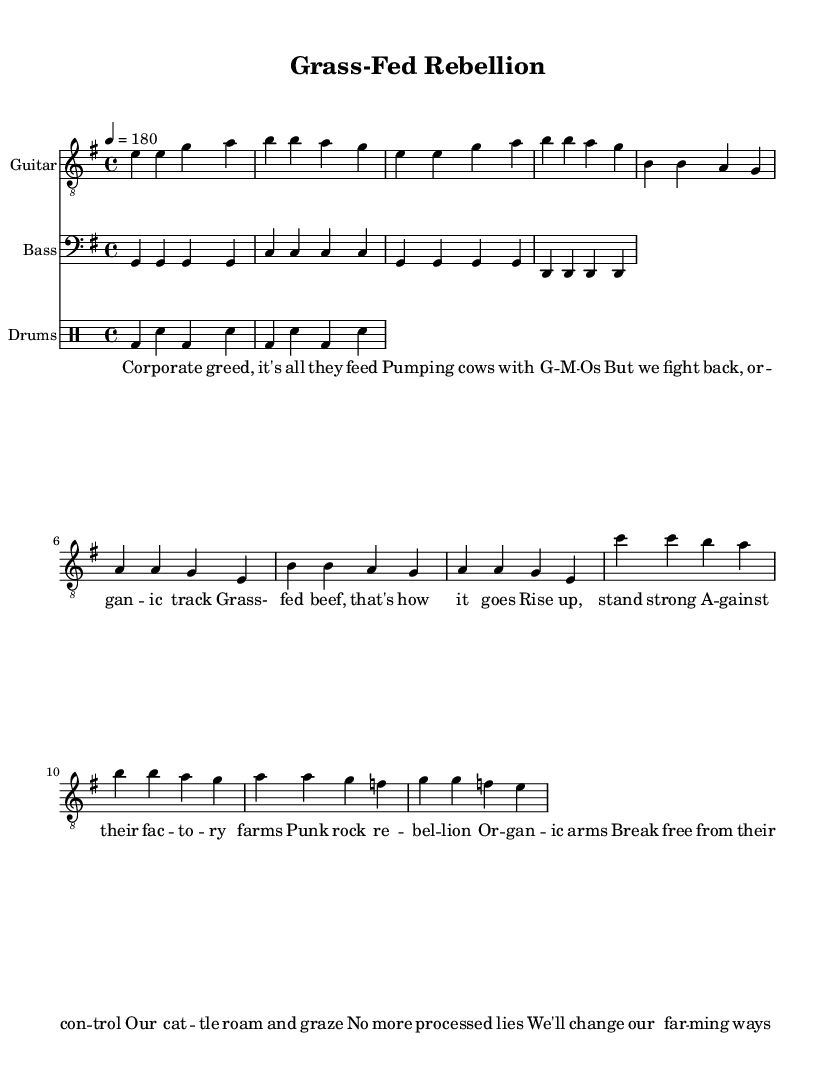What is the key signature of this music? The key signature is E minor, which has one sharp, the F#. You can identify the key signature by looking at the marks at the beginning of the staff.
Answer: E minor What is the time signature of this music? The time signature is 4/4, indicated at the beginning of the piece. This means there are four beats in each measure and the quarter note gets one beat.
Answer: 4/4 What is the tempo marking given in the music? The tempo marking is 180 beats per minute, which is specified right at the beginning of the score. This indicates the speed at which the piece should be played.
Answer: 180 How many measures are in the verse section? The verse section consists of 4 measures as indicated by the sequences of notes. You can count the groups separated by vertical lines, which represent bar lines.
Answer: 4 What type of drum pattern is used in the score? The drum pattern consists of bass drum (bd) and snare (sn) alternating, creating a simple and driving rhythm typical for punk music. You can see the note symbols in the drum staff for identification.
Answer: Bass drum and snare What is the central theme of the lyrics? The lyrics convey a message against corporate practices in farming, focusing on organic and grass-fed methods as a rebellion against industrial control. You can tell by reading through the lyric lines provided in the sheet music.
Answer: Corporate control What instruments are featured in this piece? The instruments featured are guitar, bass, and drums, each with its own staff in the score which is indicated at the top of each instrument's staff.
Answer: Guitar, bass, drums 